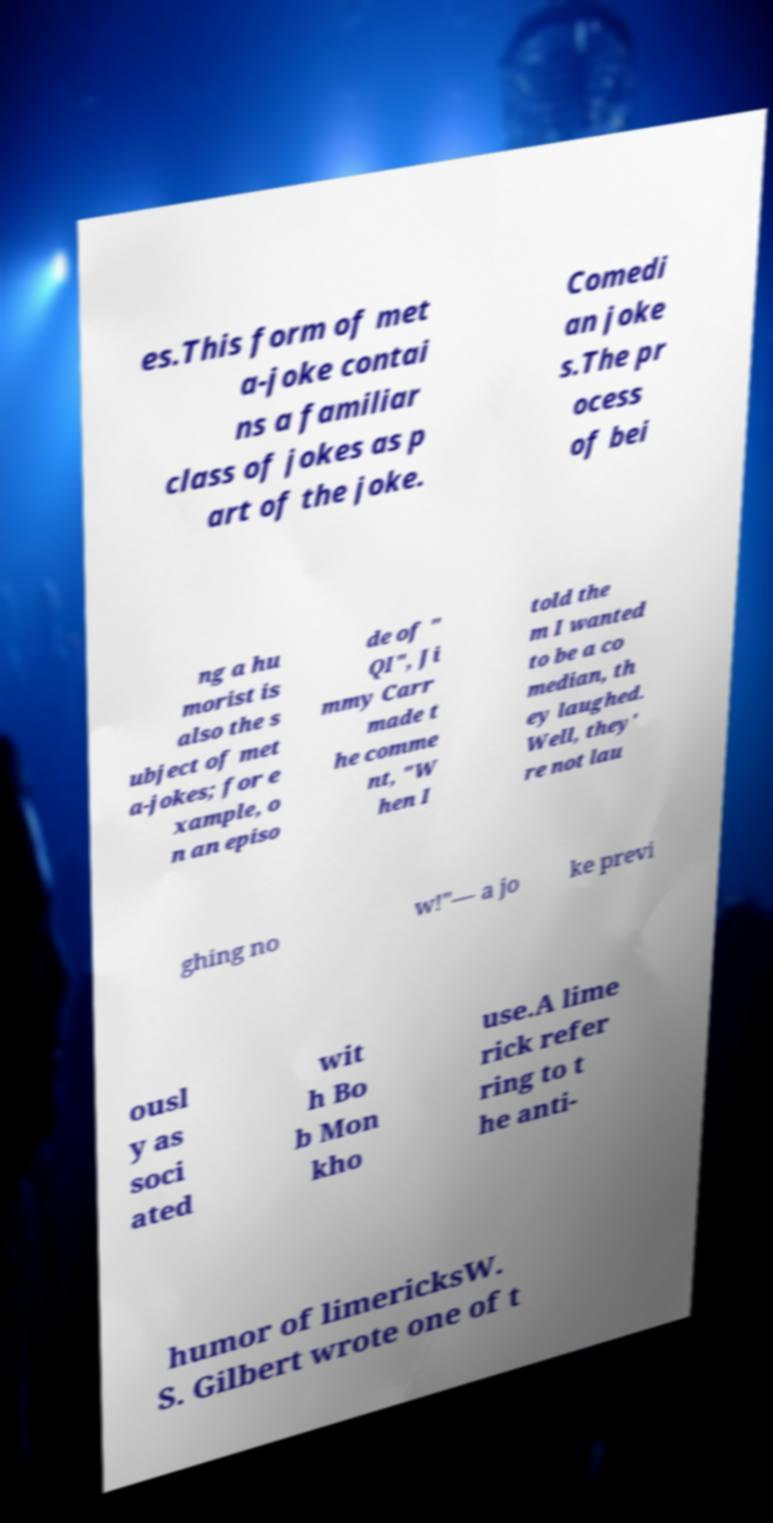Please identify and transcribe the text found in this image. es.This form of met a-joke contai ns a familiar class of jokes as p art of the joke. Comedi an joke s.The pr ocess of bei ng a hu morist is also the s ubject of met a-jokes; for e xample, o n an episo de of " QI", Ji mmy Carr made t he comme nt, "W hen I told the m I wanted to be a co median, th ey laughed. Well, they' re not lau ghing no w!"— a jo ke previ ousl y as soci ated wit h Bo b Mon kho use.A lime rick refer ring to t he anti- humor of limericksW. S. Gilbert wrote one of t 